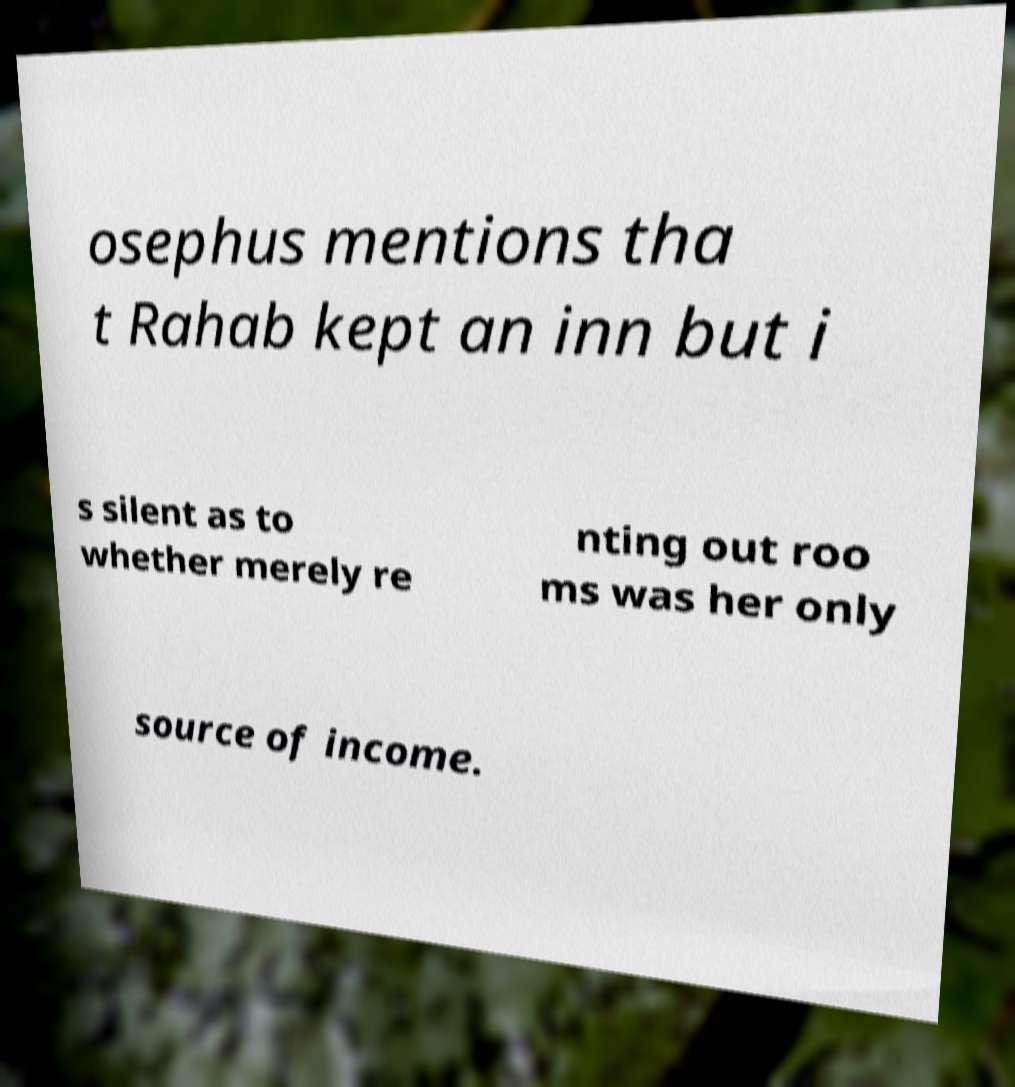For documentation purposes, I need the text within this image transcribed. Could you provide that? osephus mentions tha t Rahab kept an inn but i s silent as to whether merely re nting out roo ms was her only source of income. 